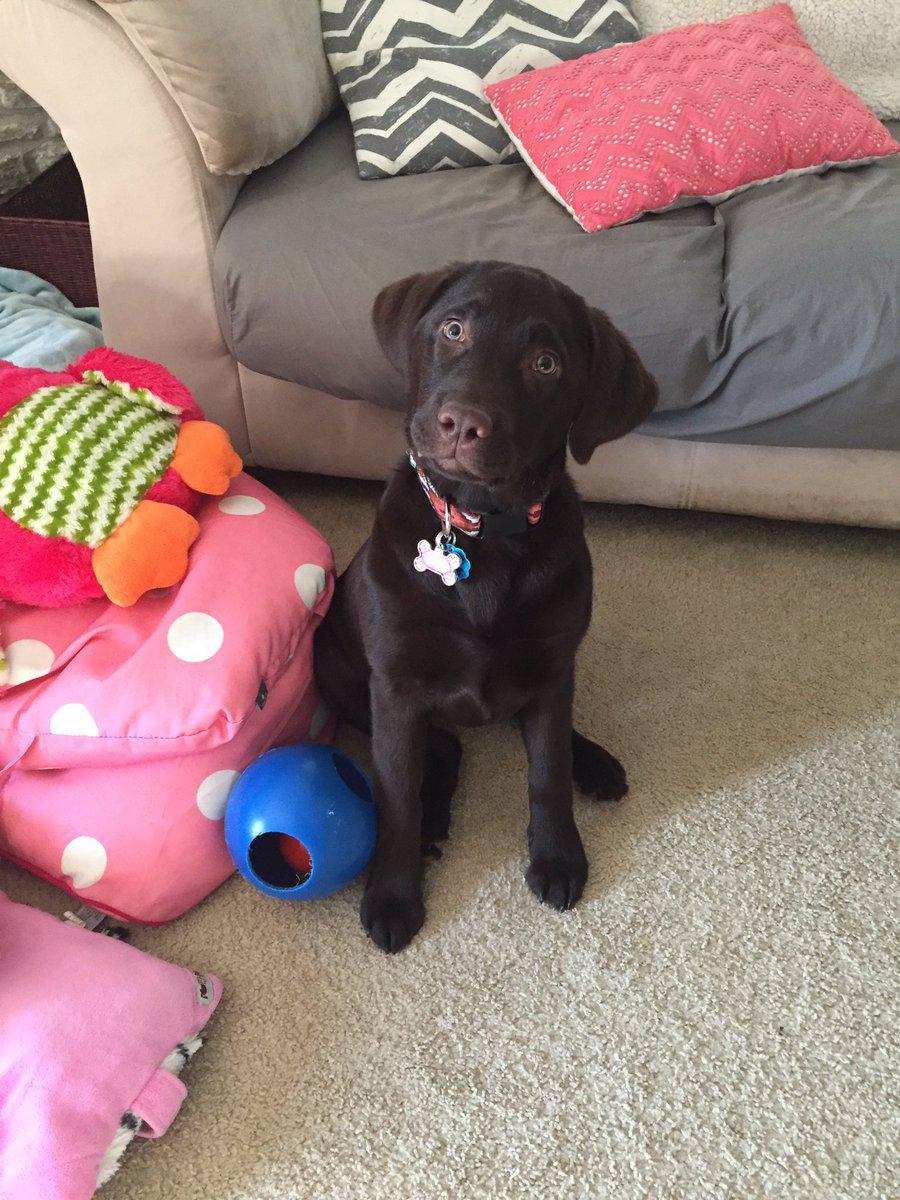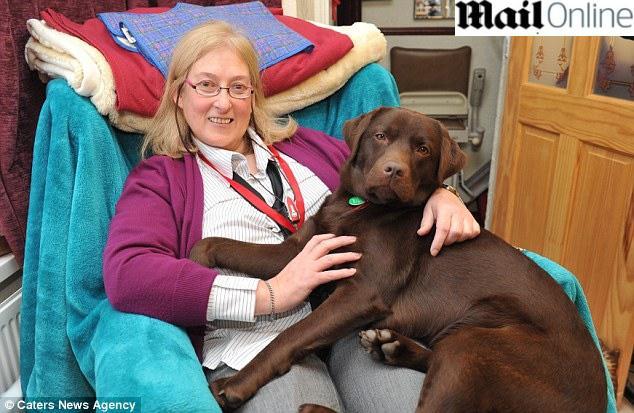The first image is the image on the left, the second image is the image on the right. Analyze the images presented: Is the assertion "a human is posing with a brown lab" valid? Answer yes or no. Yes. The first image is the image on the left, the second image is the image on the right. For the images shown, is this caption "There is one human and one dog in the right image." true? Answer yes or no. Yes. 